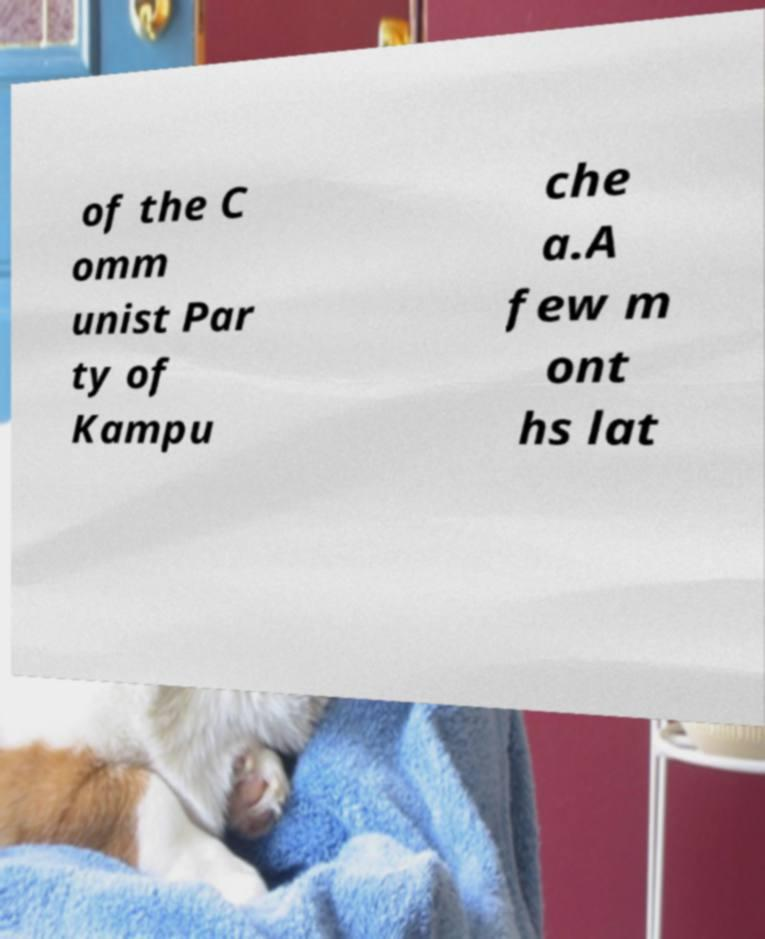There's text embedded in this image that I need extracted. Can you transcribe it verbatim? of the C omm unist Par ty of Kampu che a.A few m ont hs lat 